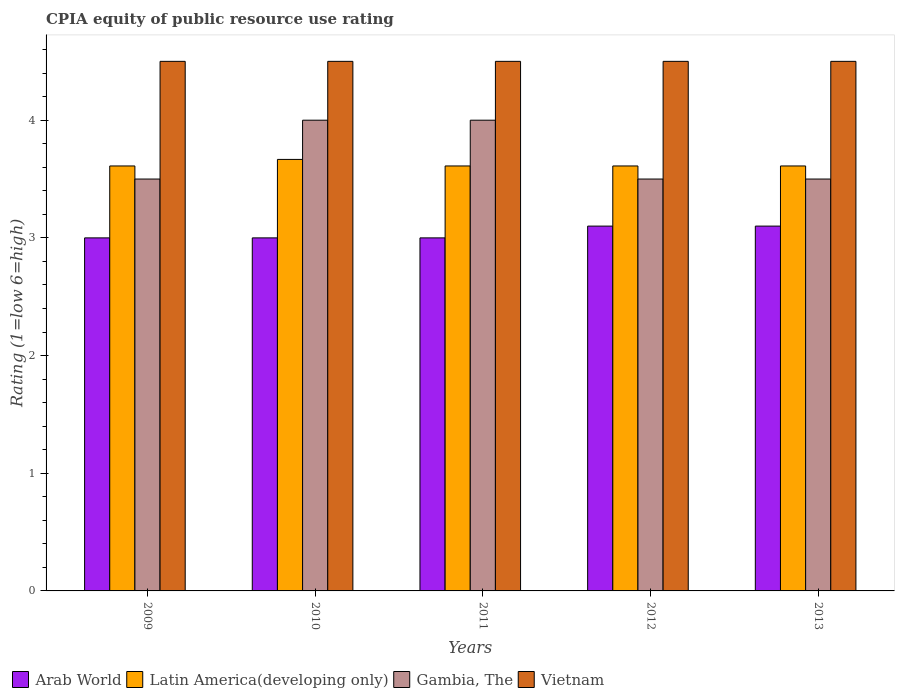How many groups of bars are there?
Offer a very short reply. 5. Are the number of bars per tick equal to the number of legend labels?
Keep it short and to the point. Yes. How many bars are there on the 3rd tick from the left?
Keep it short and to the point. 4. How many bars are there on the 2nd tick from the right?
Your response must be concise. 4. What is the label of the 1st group of bars from the left?
Make the answer very short. 2009. In how many cases, is the number of bars for a given year not equal to the number of legend labels?
Give a very brief answer. 0. What is the CPIA rating in Gambia, The in 2011?
Give a very brief answer. 4. Across all years, what is the maximum CPIA rating in Vietnam?
Offer a terse response. 4.5. In which year was the CPIA rating in Gambia, The maximum?
Your answer should be compact. 2010. In which year was the CPIA rating in Arab World minimum?
Keep it short and to the point. 2009. What is the total CPIA rating in Gambia, The in the graph?
Ensure brevity in your answer.  18.5. What is the difference between the CPIA rating in Gambia, The in 2010 and the CPIA rating in Latin America(developing only) in 2009?
Provide a succinct answer. 0.39. What is the average CPIA rating in Arab World per year?
Provide a short and direct response. 3.04. In the year 2011, what is the difference between the CPIA rating in Latin America(developing only) and CPIA rating in Vietnam?
Offer a terse response. -0.89. What is the ratio of the CPIA rating in Gambia, The in 2009 to that in 2012?
Make the answer very short. 1. Is the CPIA rating in Arab World in 2012 less than that in 2013?
Your answer should be compact. No. Is the difference between the CPIA rating in Latin America(developing only) in 2009 and 2013 greater than the difference between the CPIA rating in Vietnam in 2009 and 2013?
Make the answer very short. No. What is the difference between the highest and the second highest CPIA rating in Latin America(developing only)?
Offer a very short reply. 0.06. What is the difference between the highest and the lowest CPIA rating in Vietnam?
Provide a succinct answer. 0. Is it the case that in every year, the sum of the CPIA rating in Latin America(developing only) and CPIA rating in Vietnam is greater than the sum of CPIA rating in Arab World and CPIA rating in Gambia, The?
Keep it short and to the point. No. What does the 4th bar from the left in 2011 represents?
Offer a terse response. Vietnam. What does the 2nd bar from the right in 2013 represents?
Provide a short and direct response. Gambia, The. How many bars are there?
Ensure brevity in your answer.  20. What is the difference between two consecutive major ticks on the Y-axis?
Make the answer very short. 1. Are the values on the major ticks of Y-axis written in scientific E-notation?
Give a very brief answer. No. Does the graph contain grids?
Ensure brevity in your answer.  No. How many legend labels are there?
Give a very brief answer. 4. What is the title of the graph?
Provide a short and direct response. CPIA equity of public resource use rating. Does "Liechtenstein" appear as one of the legend labels in the graph?
Make the answer very short. No. What is the label or title of the X-axis?
Keep it short and to the point. Years. What is the Rating (1=low 6=high) in Arab World in 2009?
Give a very brief answer. 3. What is the Rating (1=low 6=high) of Latin America(developing only) in 2009?
Your answer should be very brief. 3.61. What is the Rating (1=low 6=high) in Vietnam in 2009?
Your response must be concise. 4.5. What is the Rating (1=low 6=high) of Latin America(developing only) in 2010?
Keep it short and to the point. 3.67. What is the Rating (1=low 6=high) of Arab World in 2011?
Offer a terse response. 3. What is the Rating (1=low 6=high) in Latin America(developing only) in 2011?
Give a very brief answer. 3.61. What is the Rating (1=low 6=high) of Gambia, The in 2011?
Your response must be concise. 4. What is the Rating (1=low 6=high) in Vietnam in 2011?
Your answer should be compact. 4.5. What is the Rating (1=low 6=high) of Latin America(developing only) in 2012?
Your answer should be compact. 3.61. What is the Rating (1=low 6=high) of Gambia, The in 2012?
Your answer should be compact. 3.5. What is the Rating (1=low 6=high) of Vietnam in 2012?
Make the answer very short. 4.5. What is the Rating (1=low 6=high) in Arab World in 2013?
Your answer should be very brief. 3.1. What is the Rating (1=low 6=high) in Latin America(developing only) in 2013?
Your answer should be compact. 3.61. What is the Rating (1=low 6=high) in Gambia, The in 2013?
Keep it short and to the point. 3.5. Across all years, what is the maximum Rating (1=low 6=high) in Latin America(developing only)?
Provide a succinct answer. 3.67. Across all years, what is the minimum Rating (1=low 6=high) of Arab World?
Your response must be concise. 3. Across all years, what is the minimum Rating (1=low 6=high) of Latin America(developing only)?
Your answer should be compact. 3.61. Across all years, what is the minimum Rating (1=low 6=high) in Gambia, The?
Your answer should be very brief. 3.5. What is the total Rating (1=low 6=high) of Latin America(developing only) in the graph?
Provide a short and direct response. 18.11. What is the total Rating (1=low 6=high) of Gambia, The in the graph?
Your answer should be very brief. 18.5. What is the difference between the Rating (1=low 6=high) in Latin America(developing only) in 2009 and that in 2010?
Your answer should be compact. -0.06. What is the difference between the Rating (1=low 6=high) of Gambia, The in 2009 and that in 2010?
Ensure brevity in your answer.  -0.5. What is the difference between the Rating (1=low 6=high) of Arab World in 2009 and that in 2011?
Ensure brevity in your answer.  0. What is the difference between the Rating (1=low 6=high) of Latin America(developing only) in 2009 and that in 2011?
Make the answer very short. 0. What is the difference between the Rating (1=low 6=high) of Gambia, The in 2009 and that in 2011?
Provide a short and direct response. -0.5. What is the difference between the Rating (1=low 6=high) in Arab World in 2009 and that in 2012?
Offer a very short reply. -0.1. What is the difference between the Rating (1=low 6=high) in Latin America(developing only) in 2009 and that in 2012?
Give a very brief answer. 0. What is the difference between the Rating (1=low 6=high) in Vietnam in 2009 and that in 2012?
Offer a very short reply. 0. What is the difference between the Rating (1=low 6=high) in Arab World in 2009 and that in 2013?
Your response must be concise. -0.1. What is the difference between the Rating (1=low 6=high) in Gambia, The in 2009 and that in 2013?
Provide a succinct answer. 0. What is the difference between the Rating (1=low 6=high) of Latin America(developing only) in 2010 and that in 2011?
Ensure brevity in your answer.  0.06. What is the difference between the Rating (1=low 6=high) in Gambia, The in 2010 and that in 2011?
Ensure brevity in your answer.  0. What is the difference between the Rating (1=low 6=high) of Vietnam in 2010 and that in 2011?
Make the answer very short. 0. What is the difference between the Rating (1=low 6=high) in Arab World in 2010 and that in 2012?
Your answer should be very brief. -0.1. What is the difference between the Rating (1=low 6=high) of Latin America(developing only) in 2010 and that in 2012?
Give a very brief answer. 0.06. What is the difference between the Rating (1=low 6=high) in Latin America(developing only) in 2010 and that in 2013?
Provide a succinct answer. 0.06. What is the difference between the Rating (1=low 6=high) in Latin America(developing only) in 2011 and that in 2012?
Give a very brief answer. 0. What is the difference between the Rating (1=low 6=high) of Arab World in 2011 and that in 2013?
Your answer should be compact. -0.1. What is the difference between the Rating (1=low 6=high) of Latin America(developing only) in 2011 and that in 2013?
Your response must be concise. 0. What is the difference between the Rating (1=low 6=high) in Gambia, The in 2012 and that in 2013?
Give a very brief answer. 0. What is the difference between the Rating (1=low 6=high) in Arab World in 2009 and the Rating (1=low 6=high) in Vietnam in 2010?
Ensure brevity in your answer.  -1.5. What is the difference between the Rating (1=low 6=high) in Latin America(developing only) in 2009 and the Rating (1=low 6=high) in Gambia, The in 2010?
Keep it short and to the point. -0.39. What is the difference between the Rating (1=low 6=high) of Latin America(developing only) in 2009 and the Rating (1=low 6=high) of Vietnam in 2010?
Offer a very short reply. -0.89. What is the difference between the Rating (1=low 6=high) in Gambia, The in 2009 and the Rating (1=low 6=high) in Vietnam in 2010?
Offer a terse response. -1. What is the difference between the Rating (1=low 6=high) of Arab World in 2009 and the Rating (1=low 6=high) of Latin America(developing only) in 2011?
Your answer should be compact. -0.61. What is the difference between the Rating (1=low 6=high) of Arab World in 2009 and the Rating (1=low 6=high) of Gambia, The in 2011?
Keep it short and to the point. -1. What is the difference between the Rating (1=low 6=high) in Latin America(developing only) in 2009 and the Rating (1=low 6=high) in Gambia, The in 2011?
Make the answer very short. -0.39. What is the difference between the Rating (1=low 6=high) of Latin America(developing only) in 2009 and the Rating (1=low 6=high) of Vietnam in 2011?
Provide a succinct answer. -0.89. What is the difference between the Rating (1=low 6=high) in Gambia, The in 2009 and the Rating (1=low 6=high) in Vietnam in 2011?
Offer a terse response. -1. What is the difference between the Rating (1=low 6=high) in Arab World in 2009 and the Rating (1=low 6=high) in Latin America(developing only) in 2012?
Your answer should be compact. -0.61. What is the difference between the Rating (1=low 6=high) of Arab World in 2009 and the Rating (1=low 6=high) of Gambia, The in 2012?
Provide a succinct answer. -0.5. What is the difference between the Rating (1=low 6=high) of Latin America(developing only) in 2009 and the Rating (1=low 6=high) of Vietnam in 2012?
Ensure brevity in your answer.  -0.89. What is the difference between the Rating (1=low 6=high) of Gambia, The in 2009 and the Rating (1=low 6=high) of Vietnam in 2012?
Your answer should be compact. -1. What is the difference between the Rating (1=low 6=high) of Arab World in 2009 and the Rating (1=low 6=high) of Latin America(developing only) in 2013?
Provide a succinct answer. -0.61. What is the difference between the Rating (1=low 6=high) of Arab World in 2009 and the Rating (1=low 6=high) of Gambia, The in 2013?
Your answer should be very brief. -0.5. What is the difference between the Rating (1=low 6=high) of Arab World in 2009 and the Rating (1=low 6=high) of Vietnam in 2013?
Give a very brief answer. -1.5. What is the difference between the Rating (1=low 6=high) of Latin America(developing only) in 2009 and the Rating (1=low 6=high) of Vietnam in 2013?
Your response must be concise. -0.89. What is the difference between the Rating (1=low 6=high) of Arab World in 2010 and the Rating (1=low 6=high) of Latin America(developing only) in 2011?
Give a very brief answer. -0.61. What is the difference between the Rating (1=low 6=high) of Arab World in 2010 and the Rating (1=low 6=high) of Gambia, The in 2011?
Your response must be concise. -1. What is the difference between the Rating (1=low 6=high) in Latin America(developing only) in 2010 and the Rating (1=low 6=high) in Gambia, The in 2011?
Offer a terse response. -0.33. What is the difference between the Rating (1=low 6=high) in Latin America(developing only) in 2010 and the Rating (1=low 6=high) in Vietnam in 2011?
Keep it short and to the point. -0.83. What is the difference between the Rating (1=low 6=high) in Arab World in 2010 and the Rating (1=low 6=high) in Latin America(developing only) in 2012?
Your answer should be compact. -0.61. What is the difference between the Rating (1=low 6=high) in Arab World in 2010 and the Rating (1=low 6=high) in Gambia, The in 2012?
Make the answer very short. -0.5. What is the difference between the Rating (1=low 6=high) in Arab World in 2010 and the Rating (1=low 6=high) in Latin America(developing only) in 2013?
Your response must be concise. -0.61. What is the difference between the Rating (1=low 6=high) in Arab World in 2010 and the Rating (1=low 6=high) in Gambia, The in 2013?
Provide a succinct answer. -0.5. What is the difference between the Rating (1=low 6=high) in Arab World in 2010 and the Rating (1=low 6=high) in Vietnam in 2013?
Your answer should be very brief. -1.5. What is the difference between the Rating (1=low 6=high) of Latin America(developing only) in 2010 and the Rating (1=low 6=high) of Gambia, The in 2013?
Your answer should be compact. 0.17. What is the difference between the Rating (1=low 6=high) in Gambia, The in 2010 and the Rating (1=low 6=high) in Vietnam in 2013?
Keep it short and to the point. -0.5. What is the difference between the Rating (1=low 6=high) in Arab World in 2011 and the Rating (1=low 6=high) in Latin America(developing only) in 2012?
Offer a terse response. -0.61. What is the difference between the Rating (1=low 6=high) in Arab World in 2011 and the Rating (1=low 6=high) in Gambia, The in 2012?
Ensure brevity in your answer.  -0.5. What is the difference between the Rating (1=low 6=high) in Latin America(developing only) in 2011 and the Rating (1=low 6=high) in Gambia, The in 2012?
Keep it short and to the point. 0.11. What is the difference between the Rating (1=low 6=high) in Latin America(developing only) in 2011 and the Rating (1=low 6=high) in Vietnam in 2012?
Offer a very short reply. -0.89. What is the difference between the Rating (1=low 6=high) of Gambia, The in 2011 and the Rating (1=low 6=high) of Vietnam in 2012?
Provide a succinct answer. -0.5. What is the difference between the Rating (1=low 6=high) of Arab World in 2011 and the Rating (1=low 6=high) of Latin America(developing only) in 2013?
Give a very brief answer. -0.61. What is the difference between the Rating (1=low 6=high) of Latin America(developing only) in 2011 and the Rating (1=low 6=high) of Gambia, The in 2013?
Make the answer very short. 0.11. What is the difference between the Rating (1=low 6=high) in Latin America(developing only) in 2011 and the Rating (1=low 6=high) in Vietnam in 2013?
Provide a succinct answer. -0.89. What is the difference between the Rating (1=low 6=high) in Gambia, The in 2011 and the Rating (1=low 6=high) in Vietnam in 2013?
Make the answer very short. -0.5. What is the difference between the Rating (1=low 6=high) in Arab World in 2012 and the Rating (1=low 6=high) in Latin America(developing only) in 2013?
Provide a short and direct response. -0.51. What is the difference between the Rating (1=low 6=high) in Arab World in 2012 and the Rating (1=low 6=high) in Gambia, The in 2013?
Give a very brief answer. -0.4. What is the difference between the Rating (1=low 6=high) in Latin America(developing only) in 2012 and the Rating (1=low 6=high) in Vietnam in 2013?
Offer a terse response. -0.89. What is the average Rating (1=low 6=high) in Arab World per year?
Your answer should be compact. 3.04. What is the average Rating (1=low 6=high) in Latin America(developing only) per year?
Your response must be concise. 3.62. What is the average Rating (1=low 6=high) of Gambia, The per year?
Make the answer very short. 3.7. What is the average Rating (1=low 6=high) in Vietnam per year?
Offer a terse response. 4.5. In the year 2009, what is the difference between the Rating (1=low 6=high) of Arab World and Rating (1=low 6=high) of Latin America(developing only)?
Ensure brevity in your answer.  -0.61. In the year 2009, what is the difference between the Rating (1=low 6=high) in Arab World and Rating (1=low 6=high) in Vietnam?
Your response must be concise. -1.5. In the year 2009, what is the difference between the Rating (1=low 6=high) of Latin America(developing only) and Rating (1=low 6=high) of Vietnam?
Your answer should be very brief. -0.89. In the year 2009, what is the difference between the Rating (1=low 6=high) of Gambia, The and Rating (1=low 6=high) of Vietnam?
Your answer should be compact. -1. In the year 2010, what is the difference between the Rating (1=low 6=high) in Arab World and Rating (1=low 6=high) in Vietnam?
Ensure brevity in your answer.  -1.5. In the year 2010, what is the difference between the Rating (1=low 6=high) in Latin America(developing only) and Rating (1=low 6=high) in Gambia, The?
Your answer should be compact. -0.33. In the year 2010, what is the difference between the Rating (1=low 6=high) in Latin America(developing only) and Rating (1=low 6=high) in Vietnam?
Offer a very short reply. -0.83. In the year 2011, what is the difference between the Rating (1=low 6=high) of Arab World and Rating (1=low 6=high) of Latin America(developing only)?
Your response must be concise. -0.61. In the year 2011, what is the difference between the Rating (1=low 6=high) in Arab World and Rating (1=low 6=high) in Vietnam?
Offer a very short reply. -1.5. In the year 2011, what is the difference between the Rating (1=low 6=high) in Latin America(developing only) and Rating (1=low 6=high) in Gambia, The?
Ensure brevity in your answer.  -0.39. In the year 2011, what is the difference between the Rating (1=low 6=high) of Latin America(developing only) and Rating (1=low 6=high) of Vietnam?
Provide a succinct answer. -0.89. In the year 2012, what is the difference between the Rating (1=low 6=high) in Arab World and Rating (1=low 6=high) in Latin America(developing only)?
Provide a short and direct response. -0.51. In the year 2012, what is the difference between the Rating (1=low 6=high) in Arab World and Rating (1=low 6=high) in Gambia, The?
Make the answer very short. -0.4. In the year 2012, what is the difference between the Rating (1=low 6=high) in Latin America(developing only) and Rating (1=low 6=high) in Gambia, The?
Offer a terse response. 0.11. In the year 2012, what is the difference between the Rating (1=low 6=high) in Latin America(developing only) and Rating (1=low 6=high) in Vietnam?
Ensure brevity in your answer.  -0.89. In the year 2012, what is the difference between the Rating (1=low 6=high) in Gambia, The and Rating (1=low 6=high) in Vietnam?
Keep it short and to the point. -1. In the year 2013, what is the difference between the Rating (1=low 6=high) in Arab World and Rating (1=low 6=high) in Latin America(developing only)?
Give a very brief answer. -0.51. In the year 2013, what is the difference between the Rating (1=low 6=high) in Latin America(developing only) and Rating (1=low 6=high) in Vietnam?
Provide a short and direct response. -0.89. What is the ratio of the Rating (1=low 6=high) of Vietnam in 2009 to that in 2010?
Provide a short and direct response. 1. What is the ratio of the Rating (1=low 6=high) in Arab World in 2009 to that in 2011?
Your answer should be compact. 1. What is the ratio of the Rating (1=low 6=high) in Latin America(developing only) in 2009 to that in 2011?
Give a very brief answer. 1. What is the ratio of the Rating (1=low 6=high) of Vietnam in 2009 to that in 2011?
Offer a very short reply. 1. What is the ratio of the Rating (1=low 6=high) in Latin America(developing only) in 2009 to that in 2012?
Your response must be concise. 1. What is the ratio of the Rating (1=low 6=high) in Gambia, The in 2009 to that in 2012?
Give a very brief answer. 1. What is the ratio of the Rating (1=low 6=high) of Arab World in 2009 to that in 2013?
Ensure brevity in your answer.  0.97. What is the ratio of the Rating (1=low 6=high) of Gambia, The in 2009 to that in 2013?
Give a very brief answer. 1. What is the ratio of the Rating (1=low 6=high) in Latin America(developing only) in 2010 to that in 2011?
Offer a terse response. 1.02. What is the ratio of the Rating (1=low 6=high) in Gambia, The in 2010 to that in 2011?
Your answer should be very brief. 1. What is the ratio of the Rating (1=low 6=high) of Arab World in 2010 to that in 2012?
Ensure brevity in your answer.  0.97. What is the ratio of the Rating (1=low 6=high) in Latin America(developing only) in 2010 to that in 2012?
Your answer should be compact. 1.02. What is the ratio of the Rating (1=low 6=high) in Gambia, The in 2010 to that in 2012?
Your response must be concise. 1.14. What is the ratio of the Rating (1=low 6=high) of Vietnam in 2010 to that in 2012?
Give a very brief answer. 1. What is the ratio of the Rating (1=low 6=high) of Arab World in 2010 to that in 2013?
Keep it short and to the point. 0.97. What is the ratio of the Rating (1=low 6=high) in Latin America(developing only) in 2010 to that in 2013?
Offer a terse response. 1.02. What is the ratio of the Rating (1=low 6=high) of Vietnam in 2010 to that in 2013?
Your response must be concise. 1. What is the ratio of the Rating (1=low 6=high) in Latin America(developing only) in 2011 to that in 2012?
Ensure brevity in your answer.  1. What is the ratio of the Rating (1=low 6=high) of Gambia, The in 2011 to that in 2012?
Your answer should be very brief. 1.14. What is the ratio of the Rating (1=low 6=high) of Vietnam in 2011 to that in 2012?
Give a very brief answer. 1. What is the ratio of the Rating (1=low 6=high) in Arab World in 2011 to that in 2013?
Offer a terse response. 0.97. What is the ratio of the Rating (1=low 6=high) of Vietnam in 2011 to that in 2013?
Ensure brevity in your answer.  1. What is the ratio of the Rating (1=low 6=high) in Arab World in 2012 to that in 2013?
Give a very brief answer. 1. What is the ratio of the Rating (1=low 6=high) of Gambia, The in 2012 to that in 2013?
Offer a terse response. 1. What is the ratio of the Rating (1=low 6=high) in Vietnam in 2012 to that in 2013?
Give a very brief answer. 1. What is the difference between the highest and the second highest Rating (1=low 6=high) in Arab World?
Provide a succinct answer. 0. What is the difference between the highest and the second highest Rating (1=low 6=high) of Latin America(developing only)?
Provide a short and direct response. 0.06. What is the difference between the highest and the second highest Rating (1=low 6=high) of Gambia, The?
Make the answer very short. 0. What is the difference between the highest and the second highest Rating (1=low 6=high) in Vietnam?
Keep it short and to the point. 0. What is the difference between the highest and the lowest Rating (1=low 6=high) of Latin America(developing only)?
Ensure brevity in your answer.  0.06. What is the difference between the highest and the lowest Rating (1=low 6=high) in Gambia, The?
Ensure brevity in your answer.  0.5. What is the difference between the highest and the lowest Rating (1=low 6=high) of Vietnam?
Give a very brief answer. 0. 